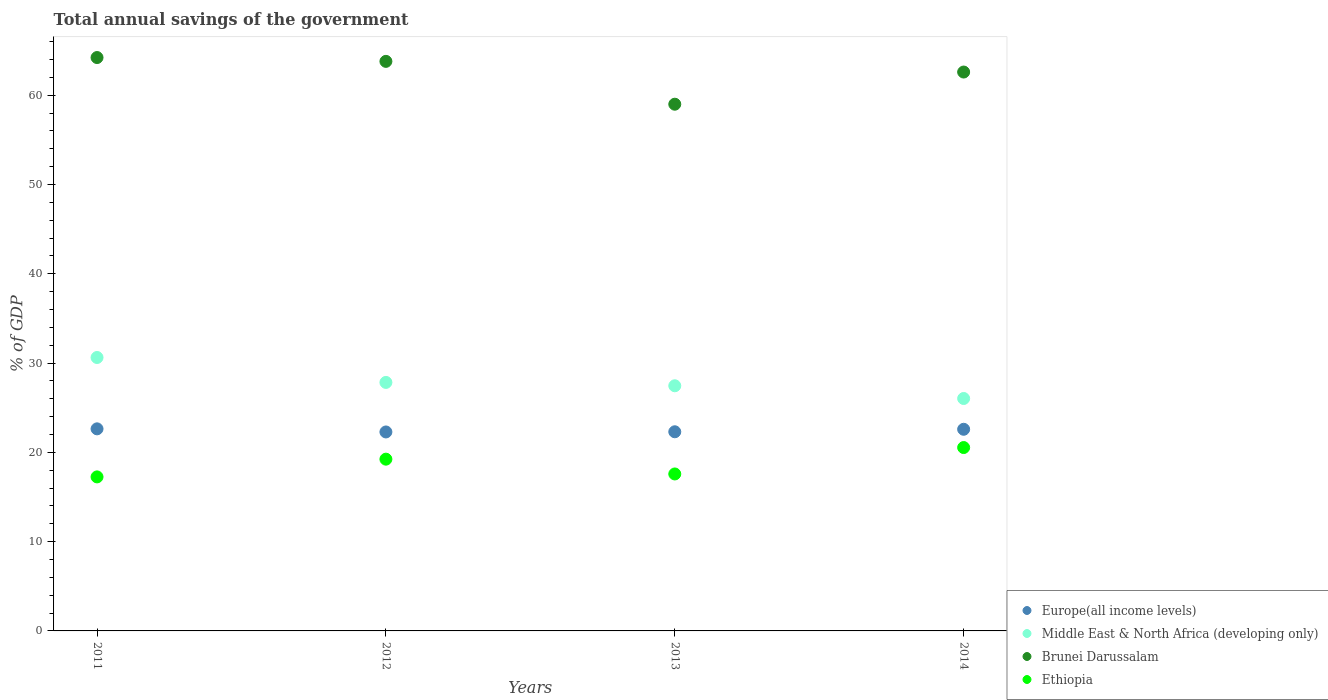How many different coloured dotlines are there?
Your response must be concise. 4. Is the number of dotlines equal to the number of legend labels?
Ensure brevity in your answer.  Yes. What is the total annual savings of the government in Brunei Darussalam in 2012?
Offer a very short reply. 63.78. Across all years, what is the maximum total annual savings of the government in Ethiopia?
Make the answer very short. 20.54. Across all years, what is the minimum total annual savings of the government in Brunei Darussalam?
Give a very brief answer. 58.99. In which year was the total annual savings of the government in Ethiopia maximum?
Offer a very short reply. 2014. In which year was the total annual savings of the government in Brunei Darussalam minimum?
Ensure brevity in your answer.  2013. What is the total total annual savings of the government in Ethiopia in the graph?
Provide a short and direct response. 74.6. What is the difference between the total annual savings of the government in Brunei Darussalam in 2011 and that in 2012?
Your answer should be compact. 0.43. What is the difference between the total annual savings of the government in Ethiopia in 2011 and the total annual savings of the government in Middle East & North Africa (developing only) in 2013?
Your response must be concise. -10.21. What is the average total annual savings of the government in Ethiopia per year?
Provide a short and direct response. 18.65. In the year 2011, what is the difference between the total annual savings of the government in Middle East & North Africa (developing only) and total annual savings of the government in Europe(all income levels)?
Your answer should be compact. 7.99. What is the ratio of the total annual savings of the government in Brunei Darussalam in 2011 to that in 2012?
Your answer should be compact. 1.01. Is the total annual savings of the government in Ethiopia in 2012 less than that in 2013?
Your response must be concise. No. Is the difference between the total annual savings of the government in Middle East & North Africa (developing only) in 2011 and 2012 greater than the difference between the total annual savings of the government in Europe(all income levels) in 2011 and 2012?
Give a very brief answer. Yes. What is the difference between the highest and the second highest total annual savings of the government in Ethiopia?
Make the answer very short. 1.3. What is the difference between the highest and the lowest total annual savings of the government in Middle East & North Africa (developing only)?
Give a very brief answer. 4.59. In how many years, is the total annual savings of the government in Ethiopia greater than the average total annual savings of the government in Ethiopia taken over all years?
Offer a very short reply. 2. Is the sum of the total annual savings of the government in Ethiopia in 2012 and 2013 greater than the maximum total annual savings of the government in Middle East & North Africa (developing only) across all years?
Make the answer very short. Yes. Is it the case that in every year, the sum of the total annual savings of the government in Brunei Darussalam and total annual savings of the government in Europe(all income levels)  is greater than the sum of total annual savings of the government in Ethiopia and total annual savings of the government in Middle East & North Africa (developing only)?
Provide a short and direct response. Yes. How many dotlines are there?
Ensure brevity in your answer.  4. Does the graph contain grids?
Your answer should be very brief. No. Where does the legend appear in the graph?
Ensure brevity in your answer.  Bottom right. How are the legend labels stacked?
Your answer should be compact. Vertical. What is the title of the graph?
Make the answer very short. Total annual savings of the government. Does "Ukraine" appear as one of the legend labels in the graph?
Give a very brief answer. No. What is the label or title of the X-axis?
Ensure brevity in your answer.  Years. What is the label or title of the Y-axis?
Offer a terse response. % of GDP. What is the % of GDP of Europe(all income levels) in 2011?
Provide a short and direct response. 22.63. What is the % of GDP in Middle East & North Africa (developing only) in 2011?
Your answer should be very brief. 30.62. What is the % of GDP in Brunei Darussalam in 2011?
Ensure brevity in your answer.  64.21. What is the % of GDP in Ethiopia in 2011?
Make the answer very short. 17.25. What is the % of GDP in Europe(all income levels) in 2012?
Make the answer very short. 22.28. What is the % of GDP in Middle East & North Africa (developing only) in 2012?
Your answer should be very brief. 27.83. What is the % of GDP in Brunei Darussalam in 2012?
Your response must be concise. 63.78. What is the % of GDP of Ethiopia in 2012?
Your response must be concise. 19.23. What is the % of GDP in Europe(all income levels) in 2013?
Provide a short and direct response. 22.3. What is the % of GDP in Middle East & North Africa (developing only) in 2013?
Your answer should be very brief. 27.45. What is the % of GDP in Brunei Darussalam in 2013?
Provide a short and direct response. 58.99. What is the % of GDP in Ethiopia in 2013?
Your answer should be very brief. 17.58. What is the % of GDP of Europe(all income levels) in 2014?
Provide a succinct answer. 22.58. What is the % of GDP of Middle East & North Africa (developing only) in 2014?
Offer a terse response. 26.03. What is the % of GDP in Brunei Darussalam in 2014?
Provide a short and direct response. 62.59. What is the % of GDP of Ethiopia in 2014?
Your response must be concise. 20.54. Across all years, what is the maximum % of GDP in Europe(all income levels)?
Give a very brief answer. 22.63. Across all years, what is the maximum % of GDP of Middle East & North Africa (developing only)?
Keep it short and to the point. 30.62. Across all years, what is the maximum % of GDP in Brunei Darussalam?
Ensure brevity in your answer.  64.21. Across all years, what is the maximum % of GDP in Ethiopia?
Give a very brief answer. 20.54. Across all years, what is the minimum % of GDP in Europe(all income levels)?
Provide a succinct answer. 22.28. Across all years, what is the minimum % of GDP of Middle East & North Africa (developing only)?
Ensure brevity in your answer.  26.03. Across all years, what is the minimum % of GDP of Brunei Darussalam?
Offer a terse response. 58.99. Across all years, what is the minimum % of GDP of Ethiopia?
Make the answer very short. 17.25. What is the total % of GDP in Europe(all income levels) in the graph?
Your answer should be compact. 89.8. What is the total % of GDP in Middle East & North Africa (developing only) in the graph?
Give a very brief answer. 111.93. What is the total % of GDP in Brunei Darussalam in the graph?
Offer a very short reply. 249.57. What is the total % of GDP of Ethiopia in the graph?
Provide a succinct answer. 74.6. What is the difference between the % of GDP of Europe(all income levels) in 2011 and that in 2012?
Give a very brief answer. 0.35. What is the difference between the % of GDP of Middle East & North Africa (developing only) in 2011 and that in 2012?
Provide a short and direct response. 2.79. What is the difference between the % of GDP of Brunei Darussalam in 2011 and that in 2012?
Keep it short and to the point. 0.43. What is the difference between the % of GDP of Ethiopia in 2011 and that in 2012?
Ensure brevity in your answer.  -1.99. What is the difference between the % of GDP of Europe(all income levels) in 2011 and that in 2013?
Provide a succinct answer. 0.33. What is the difference between the % of GDP in Middle East & North Africa (developing only) in 2011 and that in 2013?
Provide a short and direct response. 3.17. What is the difference between the % of GDP of Brunei Darussalam in 2011 and that in 2013?
Make the answer very short. 5.23. What is the difference between the % of GDP of Ethiopia in 2011 and that in 2013?
Make the answer very short. -0.33. What is the difference between the % of GDP in Europe(all income levels) in 2011 and that in 2014?
Keep it short and to the point. 0.05. What is the difference between the % of GDP in Middle East & North Africa (developing only) in 2011 and that in 2014?
Provide a short and direct response. 4.59. What is the difference between the % of GDP in Brunei Darussalam in 2011 and that in 2014?
Ensure brevity in your answer.  1.62. What is the difference between the % of GDP of Ethiopia in 2011 and that in 2014?
Provide a succinct answer. -3.29. What is the difference between the % of GDP of Europe(all income levels) in 2012 and that in 2013?
Keep it short and to the point. -0.02. What is the difference between the % of GDP in Middle East & North Africa (developing only) in 2012 and that in 2013?
Offer a very short reply. 0.37. What is the difference between the % of GDP of Brunei Darussalam in 2012 and that in 2013?
Offer a terse response. 4.8. What is the difference between the % of GDP of Ethiopia in 2012 and that in 2013?
Ensure brevity in your answer.  1.66. What is the difference between the % of GDP of Europe(all income levels) in 2012 and that in 2014?
Provide a succinct answer. -0.3. What is the difference between the % of GDP of Middle East & North Africa (developing only) in 2012 and that in 2014?
Your response must be concise. 1.8. What is the difference between the % of GDP of Brunei Darussalam in 2012 and that in 2014?
Give a very brief answer. 1.2. What is the difference between the % of GDP in Ethiopia in 2012 and that in 2014?
Offer a terse response. -1.3. What is the difference between the % of GDP in Europe(all income levels) in 2013 and that in 2014?
Give a very brief answer. -0.28. What is the difference between the % of GDP in Middle East & North Africa (developing only) in 2013 and that in 2014?
Your answer should be very brief. 1.43. What is the difference between the % of GDP of Brunei Darussalam in 2013 and that in 2014?
Offer a terse response. -3.6. What is the difference between the % of GDP in Ethiopia in 2013 and that in 2014?
Keep it short and to the point. -2.96. What is the difference between the % of GDP of Europe(all income levels) in 2011 and the % of GDP of Middle East & North Africa (developing only) in 2012?
Your answer should be very brief. -5.2. What is the difference between the % of GDP in Europe(all income levels) in 2011 and the % of GDP in Brunei Darussalam in 2012?
Your answer should be very brief. -41.15. What is the difference between the % of GDP of Europe(all income levels) in 2011 and the % of GDP of Ethiopia in 2012?
Your answer should be compact. 3.4. What is the difference between the % of GDP in Middle East & North Africa (developing only) in 2011 and the % of GDP in Brunei Darussalam in 2012?
Provide a short and direct response. -33.16. What is the difference between the % of GDP in Middle East & North Africa (developing only) in 2011 and the % of GDP in Ethiopia in 2012?
Your answer should be very brief. 11.39. What is the difference between the % of GDP of Brunei Darussalam in 2011 and the % of GDP of Ethiopia in 2012?
Your answer should be very brief. 44.98. What is the difference between the % of GDP of Europe(all income levels) in 2011 and the % of GDP of Middle East & North Africa (developing only) in 2013?
Ensure brevity in your answer.  -4.82. What is the difference between the % of GDP in Europe(all income levels) in 2011 and the % of GDP in Brunei Darussalam in 2013?
Provide a short and direct response. -36.36. What is the difference between the % of GDP in Europe(all income levels) in 2011 and the % of GDP in Ethiopia in 2013?
Provide a succinct answer. 5.05. What is the difference between the % of GDP of Middle East & North Africa (developing only) in 2011 and the % of GDP of Brunei Darussalam in 2013?
Ensure brevity in your answer.  -28.37. What is the difference between the % of GDP of Middle East & North Africa (developing only) in 2011 and the % of GDP of Ethiopia in 2013?
Provide a short and direct response. 13.04. What is the difference between the % of GDP in Brunei Darussalam in 2011 and the % of GDP in Ethiopia in 2013?
Offer a very short reply. 46.63. What is the difference between the % of GDP in Europe(all income levels) in 2011 and the % of GDP in Middle East & North Africa (developing only) in 2014?
Your response must be concise. -3.4. What is the difference between the % of GDP of Europe(all income levels) in 2011 and the % of GDP of Brunei Darussalam in 2014?
Your response must be concise. -39.96. What is the difference between the % of GDP of Europe(all income levels) in 2011 and the % of GDP of Ethiopia in 2014?
Offer a terse response. 2.09. What is the difference between the % of GDP of Middle East & North Africa (developing only) in 2011 and the % of GDP of Brunei Darussalam in 2014?
Ensure brevity in your answer.  -31.97. What is the difference between the % of GDP of Middle East & North Africa (developing only) in 2011 and the % of GDP of Ethiopia in 2014?
Give a very brief answer. 10.08. What is the difference between the % of GDP in Brunei Darussalam in 2011 and the % of GDP in Ethiopia in 2014?
Provide a short and direct response. 43.68. What is the difference between the % of GDP of Europe(all income levels) in 2012 and the % of GDP of Middle East & North Africa (developing only) in 2013?
Your answer should be very brief. -5.17. What is the difference between the % of GDP in Europe(all income levels) in 2012 and the % of GDP in Brunei Darussalam in 2013?
Offer a very short reply. -36.7. What is the difference between the % of GDP in Europe(all income levels) in 2012 and the % of GDP in Ethiopia in 2013?
Offer a terse response. 4.7. What is the difference between the % of GDP in Middle East & North Africa (developing only) in 2012 and the % of GDP in Brunei Darussalam in 2013?
Offer a terse response. -31.16. What is the difference between the % of GDP of Middle East & North Africa (developing only) in 2012 and the % of GDP of Ethiopia in 2013?
Offer a very short reply. 10.25. What is the difference between the % of GDP in Brunei Darussalam in 2012 and the % of GDP in Ethiopia in 2013?
Make the answer very short. 46.21. What is the difference between the % of GDP of Europe(all income levels) in 2012 and the % of GDP of Middle East & North Africa (developing only) in 2014?
Your answer should be very brief. -3.75. What is the difference between the % of GDP in Europe(all income levels) in 2012 and the % of GDP in Brunei Darussalam in 2014?
Your answer should be very brief. -40.31. What is the difference between the % of GDP in Europe(all income levels) in 2012 and the % of GDP in Ethiopia in 2014?
Keep it short and to the point. 1.75. What is the difference between the % of GDP in Middle East & North Africa (developing only) in 2012 and the % of GDP in Brunei Darussalam in 2014?
Offer a terse response. -34.76. What is the difference between the % of GDP in Middle East & North Africa (developing only) in 2012 and the % of GDP in Ethiopia in 2014?
Your answer should be very brief. 7.29. What is the difference between the % of GDP of Brunei Darussalam in 2012 and the % of GDP of Ethiopia in 2014?
Make the answer very short. 43.25. What is the difference between the % of GDP of Europe(all income levels) in 2013 and the % of GDP of Middle East & North Africa (developing only) in 2014?
Offer a terse response. -3.73. What is the difference between the % of GDP in Europe(all income levels) in 2013 and the % of GDP in Brunei Darussalam in 2014?
Ensure brevity in your answer.  -40.29. What is the difference between the % of GDP of Europe(all income levels) in 2013 and the % of GDP of Ethiopia in 2014?
Give a very brief answer. 1.77. What is the difference between the % of GDP in Middle East & North Africa (developing only) in 2013 and the % of GDP in Brunei Darussalam in 2014?
Offer a terse response. -35.13. What is the difference between the % of GDP in Middle East & North Africa (developing only) in 2013 and the % of GDP in Ethiopia in 2014?
Your response must be concise. 6.92. What is the difference between the % of GDP in Brunei Darussalam in 2013 and the % of GDP in Ethiopia in 2014?
Offer a terse response. 38.45. What is the average % of GDP of Europe(all income levels) per year?
Provide a short and direct response. 22.45. What is the average % of GDP of Middle East & North Africa (developing only) per year?
Ensure brevity in your answer.  27.98. What is the average % of GDP in Brunei Darussalam per year?
Provide a succinct answer. 62.39. What is the average % of GDP in Ethiopia per year?
Make the answer very short. 18.65. In the year 2011, what is the difference between the % of GDP of Europe(all income levels) and % of GDP of Middle East & North Africa (developing only)?
Keep it short and to the point. -7.99. In the year 2011, what is the difference between the % of GDP of Europe(all income levels) and % of GDP of Brunei Darussalam?
Provide a short and direct response. -41.58. In the year 2011, what is the difference between the % of GDP in Europe(all income levels) and % of GDP in Ethiopia?
Ensure brevity in your answer.  5.38. In the year 2011, what is the difference between the % of GDP of Middle East & North Africa (developing only) and % of GDP of Brunei Darussalam?
Ensure brevity in your answer.  -33.59. In the year 2011, what is the difference between the % of GDP in Middle East & North Africa (developing only) and % of GDP in Ethiopia?
Provide a succinct answer. 13.37. In the year 2011, what is the difference between the % of GDP of Brunei Darussalam and % of GDP of Ethiopia?
Keep it short and to the point. 46.96. In the year 2012, what is the difference between the % of GDP in Europe(all income levels) and % of GDP in Middle East & North Africa (developing only)?
Make the answer very short. -5.55. In the year 2012, what is the difference between the % of GDP in Europe(all income levels) and % of GDP in Brunei Darussalam?
Make the answer very short. -41.5. In the year 2012, what is the difference between the % of GDP of Europe(all income levels) and % of GDP of Ethiopia?
Make the answer very short. 3.05. In the year 2012, what is the difference between the % of GDP in Middle East & North Africa (developing only) and % of GDP in Brunei Darussalam?
Give a very brief answer. -35.95. In the year 2012, what is the difference between the % of GDP in Middle East & North Africa (developing only) and % of GDP in Ethiopia?
Your answer should be compact. 8.59. In the year 2012, what is the difference between the % of GDP of Brunei Darussalam and % of GDP of Ethiopia?
Offer a very short reply. 44.55. In the year 2013, what is the difference between the % of GDP of Europe(all income levels) and % of GDP of Middle East & North Africa (developing only)?
Keep it short and to the point. -5.15. In the year 2013, what is the difference between the % of GDP of Europe(all income levels) and % of GDP of Brunei Darussalam?
Give a very brief answer. -36.68. In the year 2013, what is the difference between the % of GDP in Europe(all income levels) and % of GDP in Ethiopia?
Ensure brevity in your answer.  4.72. In the year 2013, what is the difference between the % of GDP of Middle East & North Africa (developing only) and % of GDP of Brunei Darussalam?
Offer a terse response. -31.53. In the year 2013, what is the difference between the % of GDP of Middle East & North Africa (developing only) and % of GDP of Ethiopia?
Offer a very short reply. 9.88. In the year 2013, what is the difference between the % of GDP in Brunei Darussalam and % of GDP in Ethiopia?
Give a very brief answer. 41.41. In the year 2014, what is the difference between the % of GDP of Europe(all income levels) and % of GDP of Middle East & North Africa (developing only)?
Keep it short and to the point. -3.45. In the year 2014, what is the difference between the % of GDP of Europe(all income levels) and % of GDP of Brunei Darussalam?
Your answer should be very brief. -40.01. In the year 2014, what is the difference between the % of GDP in Europe(all income levels) and % of GDP in Ethiopia?
Your answer should be compact. 2.05. In the year 2014, what is the difference between the % of GDP of Middle East & North Africa (developing only) and % of GDP of Brunei Darussalam?
Make the answer very short. -36.56. In the year 2014, what is the difference between the % of GDP in Middle East & North Africa (developing only) and % of GDP in Ethiopia?
Provide a succinct answer. 5.49. In the year 2014, what is the difference between the % of GDP in Brunei Darussalam and % of GDP in Ethiopia?
Offer a very short reply. 42.05. What is the ratio of the % of GDP in Europe(all income levels) in 2011 to that in 2012?
Provide a succinct answer. 1.02. What is the ratio of the % of GDP in Middle East & North Africa (developing only) in 2011 to that in 2012?
Offer a very short reply. 1.1. What is the ratio of the % of GDP of Ethiopia in 2011 to that in 2012?
Provide a succinct answer. 0.9. What is the ratio of the % of GDP in Europe(all income levels) in 2011 to that in 2013?
Your answer should be very brief. 1.01. What is the ratio of the % of GDP in Middle East & North Africa (developing only) in 2011 to that in 2013?
Provide a succinct answer. 1.12. What is the ratio of the % of GDP in Brunei Darussalam in 2011 to that in 2013?
Make the answer very short. 1.09. What is the ratio of the % of GDP of Ethiopia in 2011 to that in 2013?
Your response must be concise. 0.98. What is the ratio of the % of GDP of Middle East & North Africa (developing only) in 2011 to that in 2014?
Your answer should be compact. 1.18. What is the ratio of the % of GDP of Brunei Darussalam in 2011 to that in 2014?
Offer a very short reply. 1.03. What is the ratio of the % of GDP in Ethiopia in 2011 to that in 2014?
Give a very brief answer. 0.84. What is the ratio of the % of GDP of Middle East & North Africa (developing only) in 2012 to that in 2013?
Your answer should be very brief. 1.01. What is the ratio of the % of GDP in Brunei Darussalam in 2012 to that in 2013?
Your response must be concise. 1.08. What is the ratio of the % of GDP of Ethiopia in 2012 to that in 2013?
Offer a very short reply. 1.09. What is the ratio of the % of GDP of Europe(all income levels) in 2012 to that in 2014?
Make the answer very short. 0.99. What is the ratio of the % of GDP in Middle East & North Africa (developing only) in 2012 to that in 2014?
Offer a terse response. 1.07. What is the ratio of the % of GDP of Brunei Darussalam in 2012 to that in 2014?
Offer a very short reply. 1.02. What is the ratio of the % of GDP of Ethiopia in 2012 to that in 2014?
Offer a terse response. 0.94. What is the ratio of the % of GDP in Europe(all income levels) in 2013 to that in 2014?
Provide a short and direct response. 0.99. What is the ratio of the % of GDP of Middle East & North Africa (developing only) in 2013 to that in 2014?
Provide a succinct answer. 1.05. What is the ratio of the % of GDP of Brunei Darussalam in 2013 to that in 2014?
Give a very brief answer. 0.94. What is the ratio of the % of GDP of Ethiopia in 2013 to that in 2014?
Offer a very short reply. 0.86. What is the difference between the highest and the second highest % of GDP of Europe(all income levels)?
Your answer should be very brief. 0.05. What is the difference between the highest and the second highest % of GDP of Middle East & North Africa (developing only)?
Your answer should be very brief. 2.79. What is the difference between the highest and the second highest % of GDP of Brunei Darussalam?
Make the answer very short. 0.43. What is the difference between the highest and the second highest % of GDP of Ethiopia?
Your answer should be very brief. 1.3. What is the difference between the highest and the lowest % of GDP of Europe(all income levels)?
Give a very brief answer. 0.35. What is the difference between the highest and the lowest % of GDP in Middle East & North Africa (developing only)?
Your answer should be compact. 4.59. What is the difference between the highest and the lowest % of GDP of Brunei Darussalam?
Your response must be concise. 5.23. What is the difference between the highest and the lowest % of GDP in Ethiopia?
Provide a succinct answer. 3.29. 